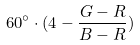Convert formula to latex. <formula><loc_0><loc_0><loc_500><loc_500>6 0 ^ { \circ } \cdot ( 4 - \frac { G - R } { B - R } )</formula> 